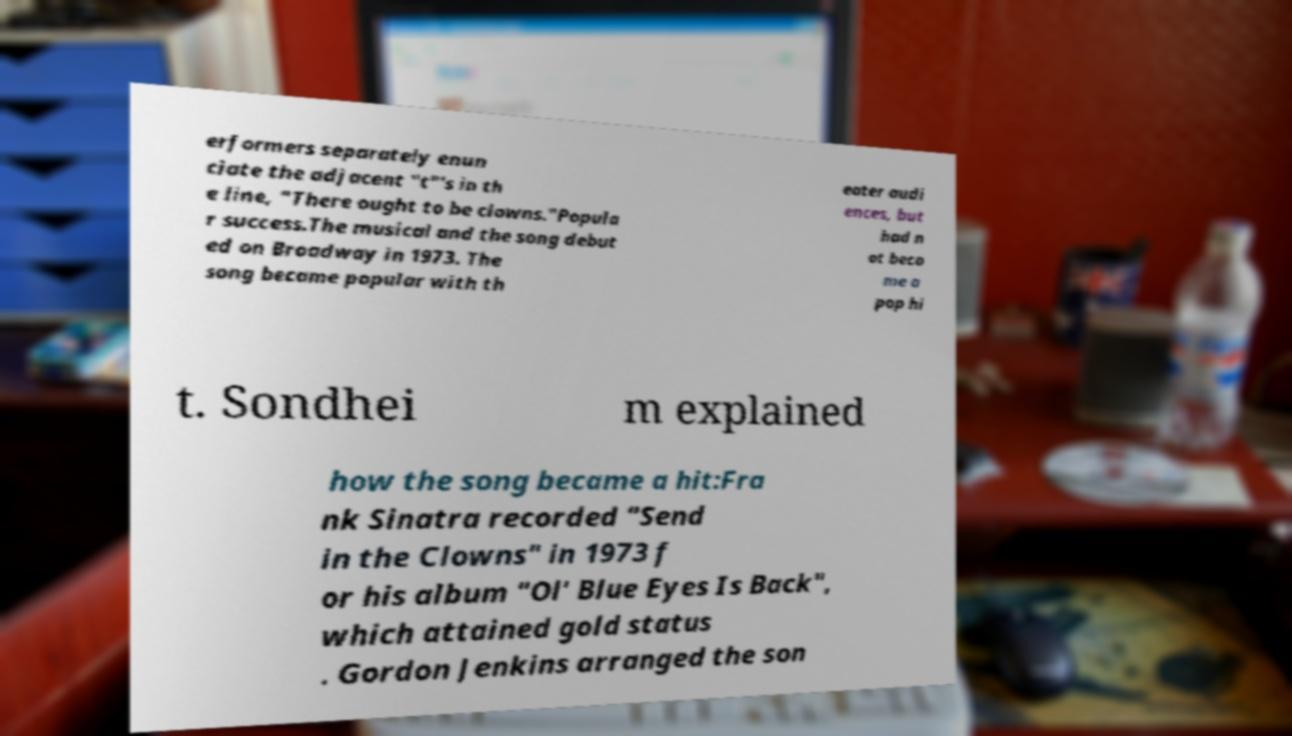What messages or text are displayed in this image? I need them in a readable, typed format. erformers separately enun ciate the adjacent "t"'s in th e line, "There ought to be clowns."Popula r success.The musical and the song debut ed on Broadway in 1973. The song became popular with th eater audi ences, but had n ot beco me a pop hi t. Sondhei m explained how the song became a hit:Fra nk Sinatra recorded "Send in the Clowns" in 1973 f or his album "Ol' Blue Eyes Is Back", which attained gold status . Gordon Jenkins arranged the son 